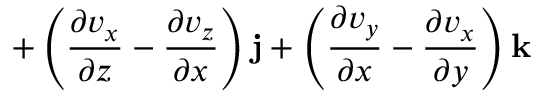Convert formula to latex. <formula><loc_0><loc_0><loc_500><loc_500>+ \left ( { \frac { \partial v _ { x } } { \partial z } } - { \frac { \partial v _ { z } } { \partial x } } \right ) j + \left ( { \frac { \partial v _ { y } } { \partial x } } - { \frac { \partial v _ { x } } { \partial y } } \right ) k</formula> 